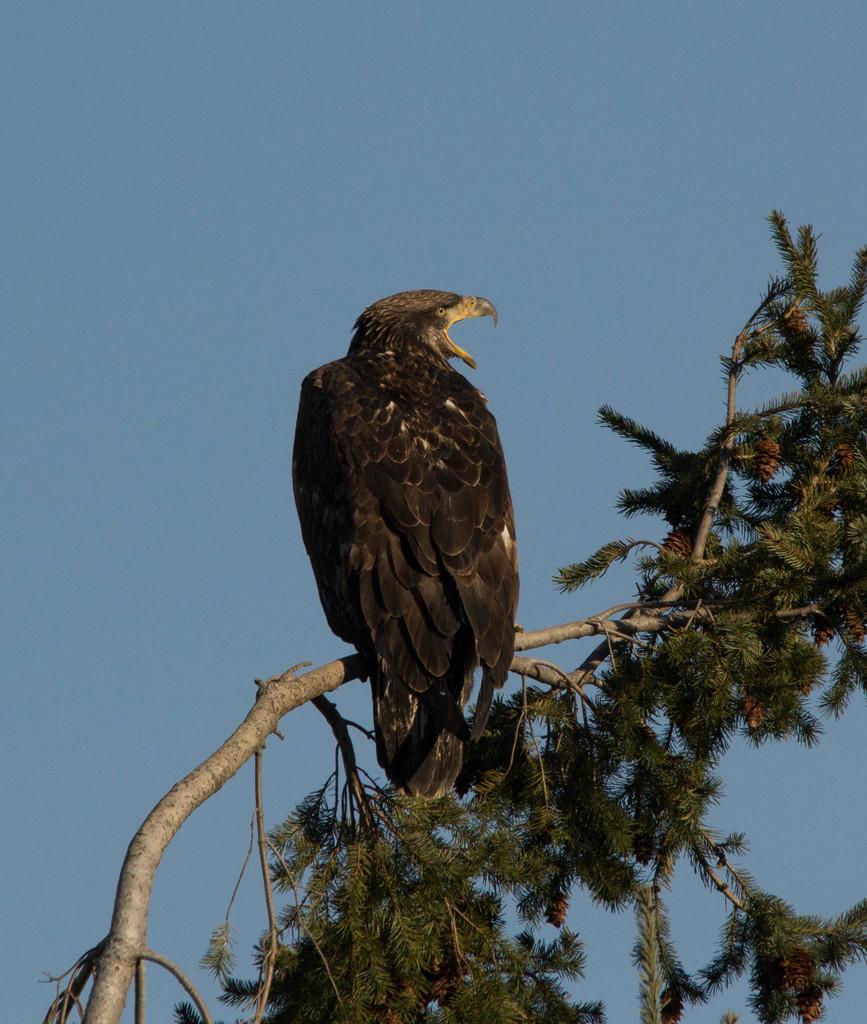Can you describe this image briefly? In the center of the image we can see a bird on the tree. In the background there is sky. 